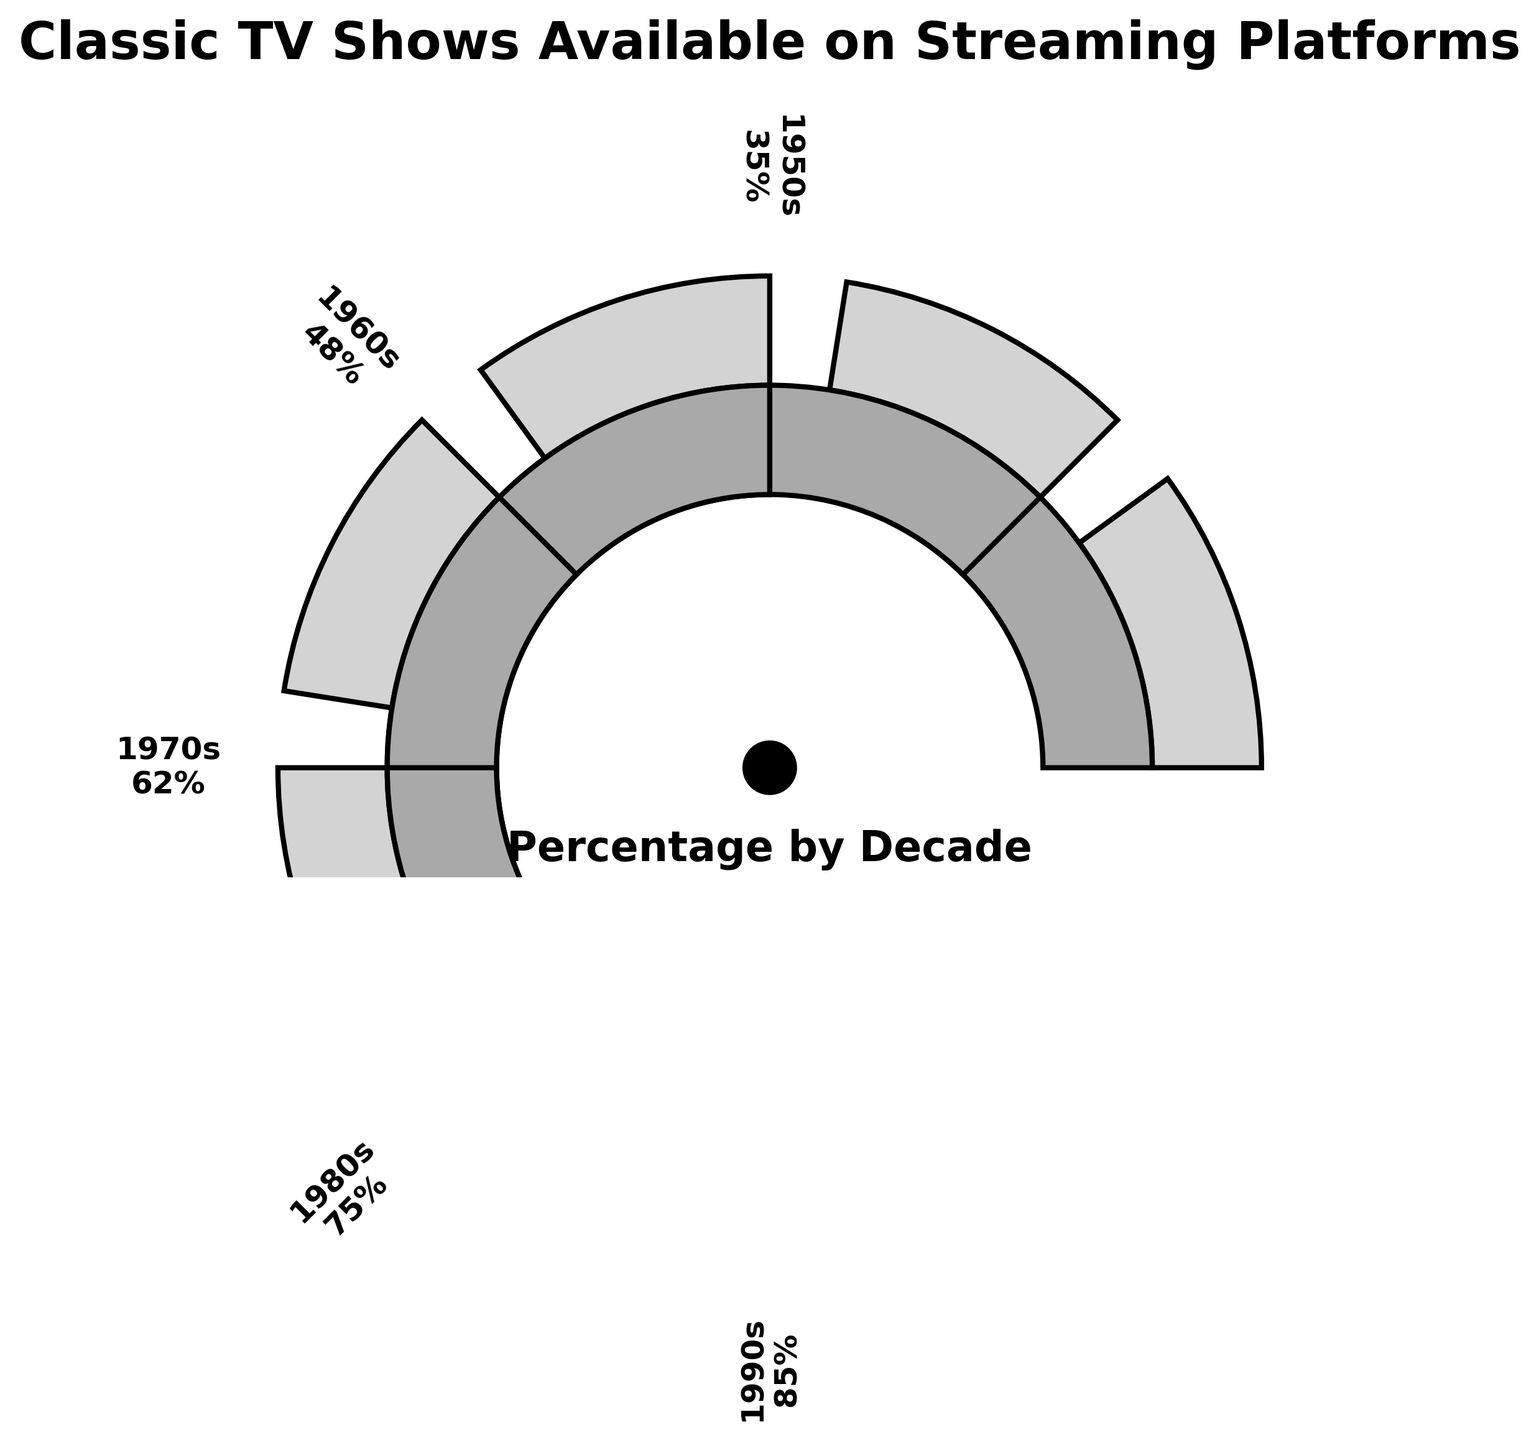How many decades are represented in the figure? Count the number of labeled sections representing decades in the gauge chart: 1950s, 1960s, 1970s, 1980s, 1990s. There are a total of 5 distinct decades.
Answer: 5 Which decade has the highest percentage of classic TV shows available on streaming platforms? Identify the labeled sections and their corresponding percentages. The 1990s section has the highest percentage at 85%.
Answer: 1990s What is the total percentage of TV shows from the 1950s and 1960s available on streaming platforms? Add the percentages of the 1950s and 1960s: 35% + 48% = 83%.
Answer: 83% What is the difference in percentage between the decade with the highest availability and the decade with the lowest availability? Subtract the percentage of the 1950s (lowest at 35%) from the 1990s (highest at 85%): 85% - 35% = 50%.
Answer: 50% Do classic TV shows from the 1980s have a greater or lesser availability than those from the 1970s? Compare the percentages: 1980s with 75% and 1970s with 62%. The 1980s have a greater availability.
Answer: Greater What is the average percentage of TV shows available from the 1950s, 1960s, and 1970s? Calculate the average: (35% + 48% + 62%) / 3 = 48.33%.
Answer: 48.33% How does the availability of TV shows from the 1970s compare to those from the 1950s? Compare the percentages: 1970s with 62% and 1950s with 35%. The 1970s have a higher availability.
Answer: Higher If you combine the availability percentages for the 1980s and 1990s, what is the total? Add the percentages for the 1980s and 1990s: 75% + 85% = 160%.
Answer: 160% Between which decades is there the smallest increase in availability percentage? Calculate the differences between successive decades: 
1960s - 1950s = 48% - 35% = 13%,
1970s - 1960s = 62% - 48% = 14%,
1980s - 1970s = 75% - 62% = 13%,
1990s - 1980s = 85% - 75% = 10%. 
The smallest increase is between the 1980s and 1990s by 10%.
Answer: 1980s to 1990s 